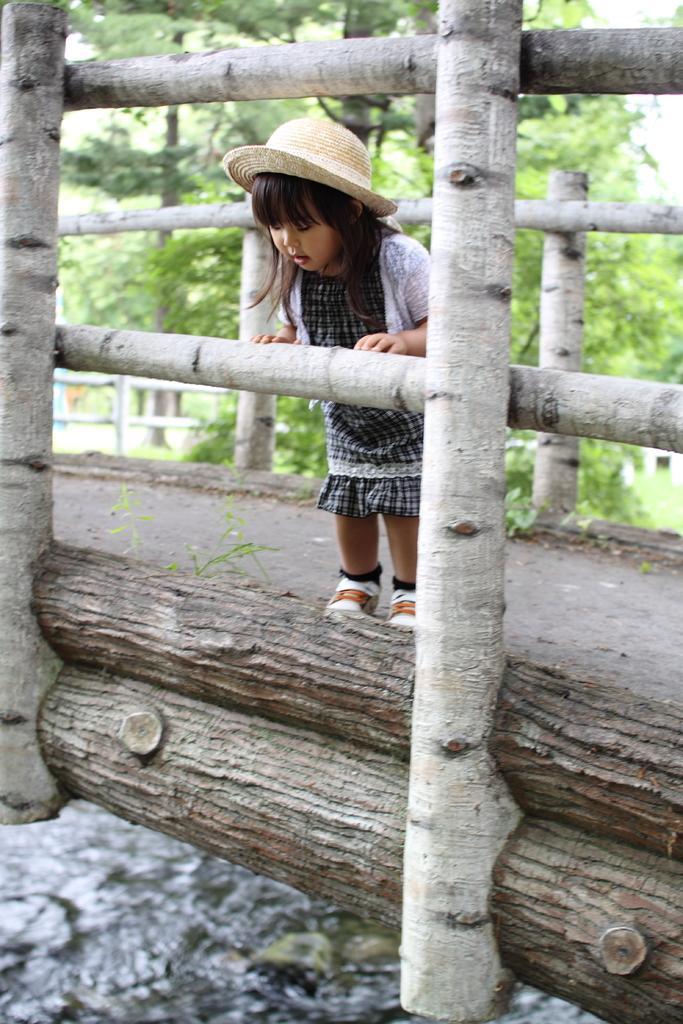Please provide a concise description of this image. In the image there is a bridge with wooden poles. On the bridge there is a girl with a hat on her head and she is standing. Below the bridge there is water. Behind the bridge there are trees. 